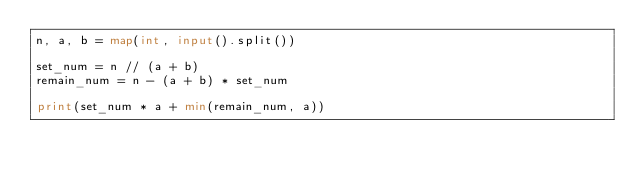Convert code to text. <code><loc_0><loc_0><loc_500><loc_500><_Python_>n, a, b = map(int, input().split())

set_num = n // (a + b)
remain_num = n - (a + b) * set_num

print(set_num * a + min(remain_num, a))
</code> 